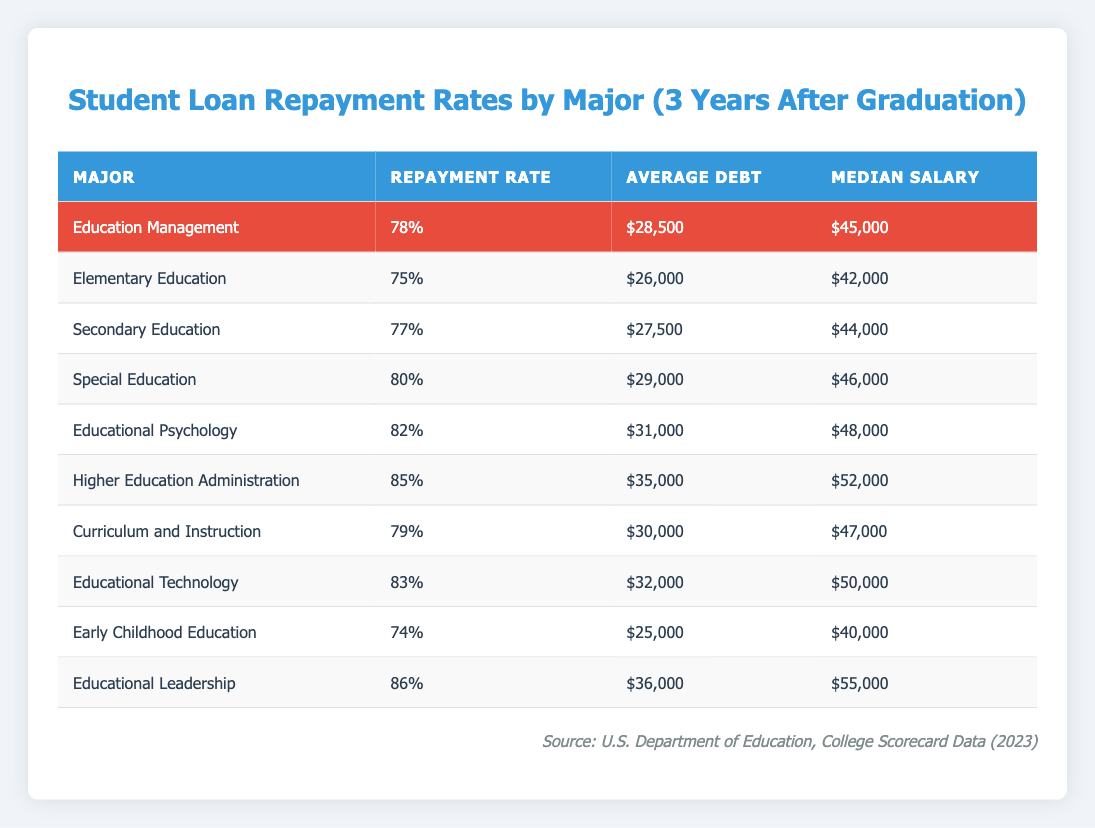What is the repayment rate for Education Management? The repayment rate for Education Management is explicitly listed in the table under the "Repayment Rate" column.
Answer: 78% Which major has the highest average debt? By reviewing the "Average Debt" column, the highest value can be identified. Comparing all values, Higher Education Administration has the highest average debt of $35,000.
Answer: Higher Education Administration Are the median salaries for Educational Leadership and Special Education equal? The median salary for Educational Leadership is $55,000, while for Special Education it is $46,000. Since the two values are different, they are not equal.
Answer: No What is the average repayment rate of the three highest repayment rates? The three highest repayment rates are Educational Leadership (86%), Higher Education Administration (85%), and Educational Psychology (82%). The average is calculated as (86 + 85 + 82) / 3 = 251 / 3 ≈ 83.67%.
Answer: 83.67% What amount of debt on average do graduates from Special Education have compared to Early Childhood Education? The average debt for Special Education is $29,000 and for Early Childhood Education, it is $25,000. The difference is calculated as $29,000 - $25,000 = $4,000, indicating that graduates from Special Education have $4,000 more in debt.
Answer: $4,000 What is the median salary for the major with the lowest repayment rate? The lowest repayment rate is for Early Childhood Education at 74%. The corresponding median salary is found in the same row in the "Median Salary" column, which is $40,000.
Answer: $40,000 Which two majors have repayment rates with a difference of less than 5%? Examining the repayment rates, Elementary Education (75%) and Secondary Education (77%) have a difference of 2%. Thus, their difference is less than 5%.
Answer: Elementary Education and Secondary Education Is the average debt greater for Educational Technology than for Curriculum and Instruction? The average debt for Educational Technology is $32,000 and for Curriculum and Instruction is $30,000. Since $32,000 is greater than $30,000, the statement is true.
Answer: Yes What major has both the highest median salary and highest repayment rate? By reviewing both the "Median Salary" and "Repayment Rate" columns, Educational Leadership has the highest median salary of $55,000 and a repayment rate of 86%. Therefore, it possesses both attributes.
Answer: Educational Leadership 